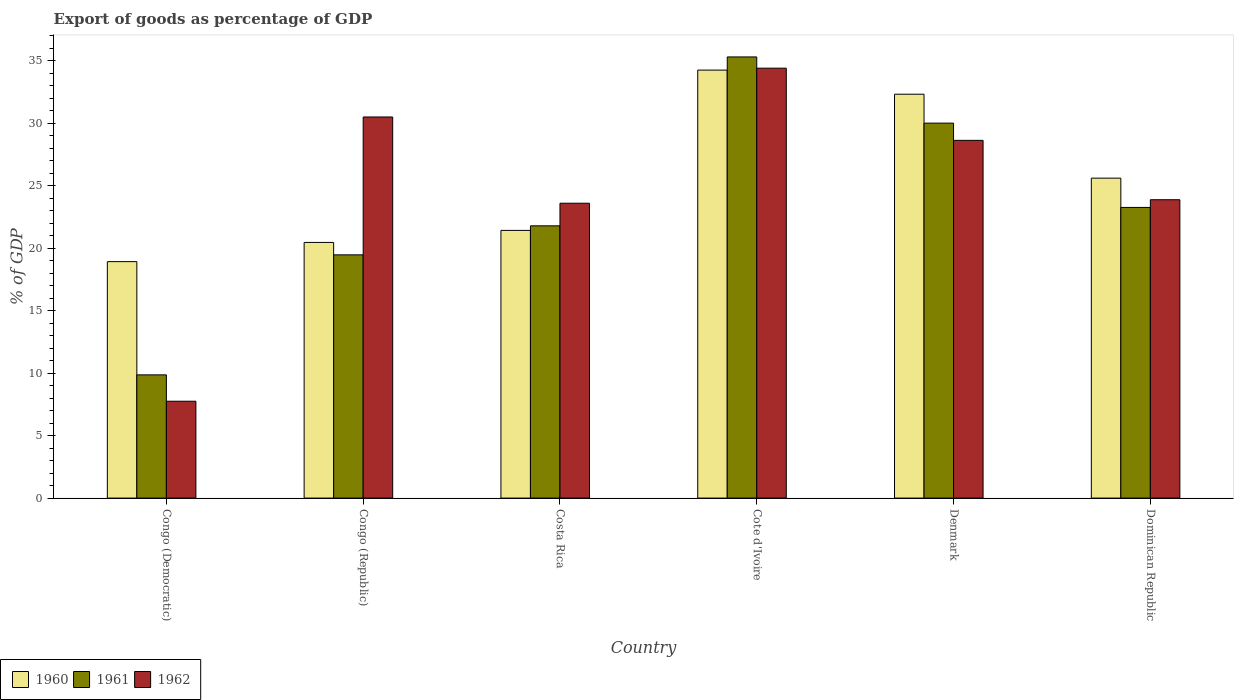How many bars are there on the 2nd tick from the right?
Your response must be concise. 3. What is the label of the 2nd group of bars from the left?
Provide a succinct answer. Congo (Republic). In how many cases, is the number of bars for a given country not equal to the number of legend labels?
Your answer should be very brief. 0. What is the export of goods as percentage of GDP in 1960 in Dominican Republic?
Offer a terse response. 25.59. Across all countries, what is the maximum export of goods as percentage of GDP in 1960?
Ensure brevity in your answer.  34.24. Across all countries, what is the minimum export of goods as percentage of GDP in 1962?
Give a very brief answer. 7.75. In which country was the export of goods as percentage of GDP in 1962 maximum?
Offer a very short reply. Cote d'Ivoire. In which country was the export of goods as percentage of GDP in 1962 minimum?
Provide a succinct answer. Congo (Democratic). What is the total export of goods as percentage of GDP in 1960 in the graph?
Your answer should be compact. 152.93. What is the difference between the export of goods as percentage of GDP in 1962 in Cote d'Ivoire and that in Dominican Republic?
Give a very brief answer. 10.52. What is the difference between the export of goods as percentage of GDP in 1962 in Dominican Republic and the export of goods as percentage of GDP in 1961 in Denmark?
Keep it short and to the point. -6.13. What is the average export of goods as percentage of GDP in 1962 per country?
Give a very brief answer. 24.78. What is the difference between the export of goods as percentage of GDP of/in 1960 and export of goods as percentage of GDP of/in 1961 in Denmark?
Offer a terse response. 2.31. What is the ratio of the export of goods as percentage of GDP in 1961 in Congo (Democratic) to that in Denmark?
Your answer should be very brief. 0.33. Is the export of goods as percentage of GDP in 1960 in Costa Rica less than that in Dominican Republic?
Keep it short and to the point. Yes. Is the difference between the export of goods as percentage of GDP in 1960 in Congo (Republic) and Costa Rica greater than the difference between the export of goods as percentage of GDP in 1961 in Congo (Republic) and Costa Rica?
Provide a succinct answer. Yes. What is the difference between the highest and the second highest export of goods as percentage of GDP in 1960?
Your answer should be compact. 6.72. What is the difference between the highest and the lowest export of goods as percentage of GDP in 1961?
Your answer should be very brief. 25.43. Is the sum of the export of goods as percentage of GDP in 1960 in Cote d'Ivoire and Denmark greater than the maximum export of goods as percentage of GDP in 1961 across all countries?
Your answer should be very brief. Yes. What does the 1st bar from the right in Congo (Republic) represents?
Your answer should be compact. 1962. Are all the bars in the graph horizontal?
Keep it short and to the point. No. What is the difference between two consecutive major ticks on the Y-axis?
Provide a short and direct response. 5. Does the graph contain grids?
Provide a short and direct response. No. How many legend labels are there?
Keep it short and to the point. 3. How are the legend labels stacked?
Provide a succinct answer. Horizontal. What is the title of the graph?
Ensure brevity in your answer.  Export of goods as percentage of GDP. Does "1989" appear as one of the legend labels in the graph?
Your answer should be compact. No. What is the label or title of the Y-axis?
Keep it short and to the point. % of GDP. What is the % of GDP of 1960 in Congo (Democratic)?
Provide a succinct answer. 18.92. What is the % of GDP in 1961 in Congo (Democratic)?
Offer a very short reply. 9.86. What is the % of GDP of 1962 in Congo (Democratic)?
Offer a terse response. 7.75. What is the % of GDP in 1960 in Congo (Republic)?
Your response must be concise. 20.45. What is the % of GDP of 1961 in Congo (Republic)?
Your answer should be compact. 19.46. What is the % of GDP of 1962 in Congo (Republic)?
Keep it short and to the point. 30.49. What is the % of GDP in 1960 in Costa Rica?
Ensure brevity in your answer.  21.42. What is the % of GDP in 1961 in Costa Rica?
Make the answer very short. 21.78. What is the % of GDP of 1962 in Costa Rica?
Keep it short and to the point. 23.59. What is the % of GDP of 1960 in Cote d'Ivoire?
Keep it short and to the point. 34.24. What is the % of GDP of 1961 in Cote d'Ivoire?
Offer a terse response. 35.29. What is the % of GDP in 1962 in Cote d'Ivoire?
Ensure brevity in your answer.  34.39. What is the % of GDP of 1960 in Denmark?
Provide a succinct answer. 32.31. What is the % of GDP of 1961 in Denmark?
Provide a succinct answer. 30. What is the % of GDP in 1962 in Denmark?
Give a very brief answer. 28.62. What is the % of GDP in 1960 in Dominican Republic?
Offer a terse response. 25.59. What is the % of GDP of 1961 in Dominican Republic?
Offer a very short reply. 23.25. What is the % of GDP in 1962 in Dominican Republic?
Offer a terse response. 23.87. Across all countries, what is the maximum % of GDP of 1960?
Make the answer very short. 34.24. Across all countries, what is the maximum % of GDP of 1961?
Ensure brevity in your answer.  35.29. Across all countries, what is the maximum % of GDP in 1962?
Keep it short and to the point. 34.39. Across all countries, what is the minimum % of GDP of 1960?
Ensure brevity in your answer.  18.92. Across all countries, what is the minimum % of GDP in 1961?
Ensure brevity in your answer.  9.86. Across all countries, what is the minimum % of GDP in 1962?
Give a very brief answer. 7.75. What is the total % of GDP in 1960 in the graph?
Provide a succinct answer. 152.93. What is the total % of GDP in 1961 in the graph?
Your response must be concise. 139.64. What is the total % of GDP in 1962 in the graph?
Make the answer very short. 148.71. What is the difference between the % of GDP in 1960 in Congo (Democratic) and that in Congo (Republic)?
Provide a succinct answer. -1.54. What is the difference between the % of GDP of 1961 in Congo (Democratic) and that in Congo (Republic)?
Make the answer very short. -9.6. What is the difference between the % of GDP in 1962 in Congo (Democratic) and that in Congo (Republic)?
Offer a very short reply. -22.74. What is the difference between the % of GDP in 1960 in Congo (Democratic) and that in Costa Rica?
Offer a terse response. -2.5. What is the difference between the % of GDP in 1961 in Congo (Democratic) and that in Costa Rica?
Give a very brief answer. -11.92. What is the difference between the % of GDP in 1962 in Congo (Democratic) and that in Costa Rica?
Your answer should be compact. -15.84. What is the difference between the % of GDP in 1960 in Congo (Democratic) and that in Cote d'Ivoire?
Ensure brevity in your answer.  -15.32. What is the difference between the % of GDP in 1961 in Congo (Democratic) and that in Cote d'Ivoire?
Your response must be concise. -25.43. What is the difference between the % of GDP in 1962 in Congo (Democratic) and that in Cote d'Ivoire?
Your answer should be very brief. -26.64. What is the difference between the % of GDP in 1960 in Congo (Democratic) and that in Denmark?
Offer a very short reply. -13.39. What is the difference between the % of GDP of 1961 in Congo (Democratic) and that in Denmark?
Make the answer very short. -20.14. What is the difference between the % of GDP of 1962 in Congo (Democratic) and that in Denmark?
Ensure brevity in your answer.  -20.87. What is the difference between the % of GDP in 1960 in Congo (Democratic) and that in Dominican Republic?
Your answer should be very brief. -6.68. What is the difference between the % of GDP in 1961 in Congo (Democratic) and that in Dominican Republic?
Keep it short and to the point. -13.4. What is the difference between the % of GDP in 1962 in Congo (Democratic) and that in Dominican Republic?
Make the answer very short. -16.12. What is the difference between the % of GDP of 1960 in Congo (Republic) and that in Costa Rica?
Keep it short and to the point. -0.96. What is the difference between the % of GDP in 1961 in Congo (Republic) and that in Costa Rica?
Give a very brief answer. -2.32. What is the difference between the % of GDP in 1962 in Congo (Republic) and that in Costa Rica?
Your response must be concise. 6.9. What is the difference between the % of GDP of 1960 in Congo (Republic) and that in Cote d'Ivoire?
Offer a terse response. -13.79. What is the difference between the % of GDP in 1961 in Congo (Republic) and that in Cote d'Ivoire?
Offer a very short reply. -15.83. What is the difference between the % of GDP in 1962 in Congo (Republic) and that in Cote d'Ivoire?
Make the answer very short. -3.9. What is the difference between the % of GDP of 1960 in Congo (Republic) and that in Denmark?
Make the answer very short. -11.86. What is the difference between the % of GDP of 1961 in Congo (Republic) and that in Denmark?
Make the answer very short. -10.54. What is the difference between the % of GDP in 1962 in Congo (Republic) and that in Denmark?
Your answer should be compact. 1.87. What is the difference between the % of GDP of 1960 in Congo (Republic) and that in Dominican Republic?
Offer a terse response. -5.14. What is the difference between the % of GDP of 1961 in Congo (Republic) and that in Dominican Republic?
Provide a short and direct response. -3.79. What is the difference between the % of GDP of 1962 in Congo (Republic) and that in Dominican Republic?
Your response must be concise. 6.62. What is the difference between the % of GDP of 1960 in Costa Rica and that in Cote d'Ivoire?
Ensure brevity in your answer.  -12.82. What is the difference between the % of GDP in 1961 in Costa Rica and that in Cote d'Ivoire?
Offer a very short reply. -13.51. What is the difference between the % of GDP of 1962 in Costa Rica and that in Cote d'Ivoire?
Your answer should be very brief. -10.8. What is the difference between the % of GDP in 1960 in Costa Rica and that in Denmark?
Your answer should be compact. -10.89. What is the difference between the % of GDP of 1961 in Costa Rica and that in Denmark?
Your answer should be compact. -8.22. What is the difference between the % of GDP in 1962 in Costa Rica and that in Denmark?
Give a very brief answer. -5.03. What is the difference between the % of GDP of 1960 in Costa Rica and that in Dominican Republic?
Give a very brief answer. -4.18. What is the difference between the % of GDP in 1961 in Costa Rica and that in Dominican Republic?
Ensure brevity in your answer.  -1.47. What is the difference between the % of GDP in 1962 in Costa Rica and that in Dominican Republic?
Ensure brevity in your answer.  -0.28. What is the difference between the % of GDP of 1960 in Cote d'Ivoire and that in Denmark?
Offer a very short reply. 1.93. What is the difference between the % of GDP of 1961 in Cote d'Ivoire and that in Denmark?
Ensure brevity in your answer.  5.3. What is the difference between the % of GDP in 1962 in Cote d'Ivoire and that in Denmark?
Your answer should be very brief. 5.77. What is the difference between the % of GDP of 1960 in Cote d'Ivoire and that in Dominican Republic?
Keep it short and to the point. 8.64. What is the difference between the % of GDP of 1961 in Cote d'Ivoire and that in Dominican Republic?
Offer a terse response. 12.04. What is the difference between the % of GDP of 1962 in Cote d'Ivoire and that in Dominican Republic?
Make the answer very short. 10.52. What is the difference between the % of GDP of 1960 in Denmark and that in Dominican Republic?
Keep it short and to the point. 6.72. What is the difference between the % of GDP of 1961 in Denmark and that in Dominican Republic?
Keep it short and to the point. 6.74. What is the difference between the % of GDP of 1962 in Denmark and that in Dominican Republic?
Keep it short and to the point. 4.75. What is the difference between the % of GDP in 1960 in Congo (Democratic) and the % of GDP in 1961 in Congo (Republic)?
Offer a terse response. -0.54. What is the difference between the % of GDP of 1960 in Congo (Democratic) and the % of GDP of 1962 in Congo (Republic)?
Your answer should be compact. -11.57. What is the difference between the % of GDP of 1961 in Congo (Democratic) and the % of GDP of 1962 in Congo (Republic)?
Ensure brevity in your answer.  -20.63. What is the difference between the % of GDP in 1960 in Congo (Democratic) and the % of GDP in 1961 in Costa Rica?
Provide a short and direct response. -2.86. What is the difference between the % of GDP in 1960 in Congo (Democratic) and the % of GDP in 1962 in Costa Rica?
Offer a terse response. -4.67. What is the difference between the % of GDP of 1961 in Congo (Democratic) and the % of GDP of 1962 in Costa Rica?
Offer a very short reply. -13.73. What is the difference between the % of GDP of 1960 in Congo (Democratic) and the % of GDP of 1961 in Cote d'Ivoire?
Your response must be concise. -16.38. What is the difference between the % of GDP in 1960 in Congo (Democratic) and the % of GDP in 1962 in Cote d'Ivoire?
Make the answer very short. -15.48. What is the difference between the % of GDP in 1961 in Congo (Democratic) and the % of GDP in 1962 in Cote d'Ivoire?
Offer a terse response. -24.53. What is the difference between the % of GDP of 1960 in Congo (Democratic) and the % of GDP of 1961 in Denmark?
Keep it short and to the point. -11.08. What is the difference between the % of GDP of 1960 in Congo (Democratic) and the % of GDP of 1962 in Denmark?
Your answer should be very brief. -9.7. What is the difference between the % of GDP in 1961 in Congo (Democratic) and the % of GDP in 1962 in Denmark?
Provide a short and direct response. -18.76. What is the difference between the % of GDP of 1960 in Congo (Democratic) and the % of GDP of 1961 in Dominican Republic?
Provide a succinct answer. -4.34. What is the difference between the % of GDP of 1960 in Congo (Democratic) and the % of GDP of 1962 in Dominican Republic?
Keep it short and to the point. -4.95. What is the difference between the % of GDP of 1961 in Congo (Democratic) and the % of GDP of 1962 in Dominican Republic?
Ensure brevity in your answer.  -14.01. What is the difference between the % of GDP of 1960 in Congo (Republic) and the % of GDP of 1961 in Costa Rica?
Keep it short and to the point. -1.33. What is the difference between the % of GDP in 1960 in Congo (Republic) and the % of GDP in 1962 in Costa Rica?
Offer a very short reply. -3.14. What is the difference between the % of GDP of 1961 in Congo (Republic) and the % of GDP of 1962 in Costa Rica?
Your answer should be compact. -4.13. What is the difference between the % of GDP of 1960 in Congo (Republic) and the % of GDP of 1961 in Cote d'Ivoire?
Keep it short and to the point. -14.84. What is the difference between the % of GDP in 1960 in Congo (Republic) and the % of GDP in 1962 in Cote d'Ivoire?
Provide a succinct answer. -13.94. What is the difference between the % of GDP in 1961 in Congo (Republic) and the % of GDP in 1962 in Cote d'Ivoire?
Make the answer very short. -14.93. What is the difference between the % of GDP in 1960 in Congo (Republic) and the % of GDP in 1961 in Denmark?
Your answer should be very brief. -9.54. What is the difference between the % of GDP of 1960 in Congo (Republic) and the % of GDP of 1962 in Denmark?
Offer a very short reply. -8.17. What is the difference between the % of GDP of 1961 in Congo (Republic) and the % of GDP of 1962 in Denmark?
Your response must be concise. -9.16. What is the difference between the % of GDP of 1960 in Congo (Republic) and the % of GDP of 1961 in Dominican Republic?
Keep it short and to the point. -2.8. What is the difference between the % of GDP of 1960 in Congo (Republic) and the % of GDP of 1962 in Dominican Republic?
Ensure brevity in your answer.  -3.42. What is the difference between the % of GDP of 1961 in Congo (Republic) and the % of GDP of 1962 in Dominican Republic?
Give a very brief answer. -4.41. What is the difference between the % of GDP in 1960 in Costa Rica and the % of GDP in 1961 in Cote d'Ivoire?
Ensure brevity in your answer.  -13.88. What is the difference between the % of GDP in 1960 in Costa Rica and the % of GDP in 1962 in Cote d'Ivoire?
Ensure brevity in your answer.  -12.98. What is the difference between the % of GDP in 1961 in Costa Rica and the % of GDP in 1962 in Cote d'Ivoire?
Offer a terse response. -12.61. What is the difference between the % of GDP in 1960 in Costa Rica and the % of GDP in 1961 in Denmark?
Ensure brevity in your answer.  -8.58. What is the difference between the % of GDP of 1960 in Costa Rica and the % of GDP of 1962 in Denmark?
Offer a terse response. -7.2. What is the difference between the % of GDP of 1961 in Costa Rica and the % of GDP of 1962 in Denmark?
Ensure brevity in your answer.  -6.84. What is the difference between the % of GDP of 1960 in Costa Rica and the % of GDP of 1961 in Dominican Republic?
Give a very brief answer. -1.84. What is the difference between the % of GDP of 1960 in Costa Rica and the % of GDP of 1962 in Dominican Republic?
Make the answer very short. -2.45. What is the difference between the % of GDP of 1961 in Costa Rica and the % of GDP of 1962 in Dominican Republic?
Keep it short and to the point. -2.09. What is the difference between the % of GDP of 1960 in Cote d'Ivoire and the % of GDP of 1961 in Denmark?
Your answer should be compact. 4.24. What is the difference between the % of GDP of 1960 in Cote d'Ivoire and the % of GDP of 1962 in Denmark?
Your answer should be compact. 5.62. What is the difference between the % of GDP in 1961 in Cote d'Ivoire and the % of GDP in 1962 in Denmark?
Give a very brief answer. 6.67. What is the difference between the % of GDP of 1960 in Cote d'Ivoire and the % of GDP of 1961 in Dominican Republic?
Ensure brevity in your answer.  10.99. What is the difference between the % of GDP of 1960 in Cote d'Ivoire and the % of GDP of 1962 in Dominican Republic?
Ensure brevity in your answer.  10.37. What is the difference between the % of GDP of 1961 in Cote d'Ivoire and the % of GDP of 1962 in Dominican Republic?
Your answer should be very brief. 11.42. What is the difference between the % of GDP in 1960 in Denmark and the % of GDP in 1961 in Dominican Republic?
Make the answer very short. 9.06. What is the difference between the % of GDP of 1960 in Denmark and the % of GDP of 1962 in Dominican Republic?
Your answer should be compact. 8.44. What is the difference between the % of GDP of 1961 in Denmark and the % of GDP of 1962 in Dominican Republic?
Ensure brevity in your answer.  6.13. What is the average % of GDP in 1960 per country?
Offer a terse response. 25.49. What is the average % of GDP in 1961 per country?
Your response must be concise. 23.27. What is the average % of GDP of 1962 per country?
Ensure brevity in your answer.  24.78. What is the difference between the % of GDP in 1960 and % of GDP in 1961 in Congo (Democratic)?
Your response must be concise. 9.06. What is the difference between the % of GDP of 1960 and % of GDP of 1962 in Congo (Democratic)?
Your answer should be compact. 11.17. What is the difference between the % of GDP of 1961 and % of GDP of 1962 in Congo (Democratic)?
Provide a succinct answer. 2.11. What is the difference between the % of GDP in 1960 and % of GDP in 1962 in Congo (Republic)?
Your answer should be very brief. -10.04. What is the difference between the % of GDP of 1961 and % of GDP of 1962 in Congo (Republic)?
Give a very brief answer. -11.03. What is the difference between the % of GDP in 1960 and % of GDP in 1961 in Costa Rica?
Offer a very short reply. -0.36. What is the difference between the % of GDP of 1960 and % of GDP of 1962 in Costa Rica?
Your answer should be very brief. -2.17. What is the difference between the % of GDP of 1961 and % of GDP of 1962 in Costa Rica?
Keep it short and to the point. -1.81. What is the difference between the % of GDP of 1960 and % of GDP of 1961 in Cote d'Ivoire?
Give a very brief answer. -1.05. What is the difference between the % of GDP in 1960 and % of GDP in 1962 in Cote d'Ivoire?
Provide a succinct answer. -0.15. What is the difference between the % of GDP of 1961 and % of GDP of 1962 in Cote d'Ivoire?
Your answer should be compact. 0.9. What is the difference between the % of GDP in 1960 and % of GDP in 1961 in Denmark?
Your answer should be very brief. 2.31. What is the difference between the % of GDP of 1960 and % of GDP of 1962 in Denmark?
Offer a very short reply. 3.69. What is the difference between the % of GDP of 1961 and % of GDP of 1962 in Denmark?
Provide a short and direct response. 1.38. What is the difference between the % of GDP in 1960 and % of GDP in 1961 in Dominican Republic?
Your answer should be compact. 2.34. What is the difference between the % of GDP of 1960 and % of GDP of 1962 in Dominican Republic?
Your answer should be compact. 1.73. What is the difference between the % of GDP of 1961 and % of GDP of 1962 in Dominican Republic?
Your answer should be very brief. -0.62. What is the ratio of the % of GDP in 1960 in Congo (Democratic) to that in Congo (Republic)?
Your answer should be very brief. 0.92. What is the ratio of the % of GDP of 1961 in Congo (Democratic) to that in Congo (Republic)?
Offer a terse response. 0.51. What is the ratio of the % of GDP in 1962 in Congo (Democratic) to that in Congo (Republic)?
Provide a succinct answer. 0.25. What is the ratio of the % of GDP in 1960 in Congo (Democratic) to that in Costa Rica?
Your response must be concise. 0.88. What is the ratio of the % of GDP in 1961 in Congo (Democratic) to that in Costa Rica?
Make the answer very short. 0.45. What is the ratio of the % of GDP of 1962 in Congo (Democratic) to that in Costa Rica?
Offer a very short reply. 0.33. What is the ratio of the % of GDP in 1960 in Congo (Democratic) to that in Cote d'Ivoire?
Keep it short and to the point. 0.55. What is the ratio of the % of GDP in 1961 in Congo (Democratic) to that in Cote d'Ivoire?
Ensure brevity in your answer.  0.28. What is the ratio of the % of GDP in 1962 in Congo (Democratic) to that in Cote d'Ivoire?
Offer a terse response. 0.23. What is the ratio of the % of GDP of 1960 in Congo (Democratic) to that in Denmark?
Your response must be concise. 0.59. What is the ratio of the % of GDP of 1961 in Congo (Democratic) to that in Denmark?
Your answer should be compact. 0.33. What is the ratio of the % of GDP in 1962 in Congo (Democratic) to that in Denmark?
Provide a short and direct response. 0.27. What is the ratio of the % of GDP of 1960 in Congo (Democratic) to that in Dominican Republic?
Offer a terse response. 0.74. What is the ratio of the % of GDP of 1961 in Congo (Democratic) to that in Dominican Republic?
Your answer should be very brief. 0.42. What is the ratio of the % of GDP of 1962 in Congo (Democratic) to that in Dominican Republic?
Provide a short and direct response. 0.32. What is the ratio of the % of GDP of 1960 in Congo (Republic) to that in Costa Rica?
Provide a short and direct response. 0.96. What is the ratio of the % of GDP of 1961 in Congo (Republic) to that in Costa Rica?
Provide a succinct answer. 0.89. What is the ratio of the % of GDP of 1962 in Congo (Republic) to that in Costa Rica?
Ensure brevity in your answer.  1.29. What is the ratio of the % of GDP of 1960 in Congo (Republic) to that in Cote d'Ivoire?
Ensure brevity in your answer.  0.6. What is the ratio of the % of GDP in 1961 in Congo (Republic) to that in Cote d'Ivoire?
Your response must be concise. 0.55. What is the ratio of the % of GDP in 1962 in Congo (Republic) to that in Cote d'Ivoire?
Your response must be concise. 0.89. What is the ratio of the % of GDP in 1960 in Congo (Republic) to that in Denmark?
Ensure brevity in your answer.  0.63. What is the ratio of the % of GDP in 1961 in Congo (Republic) to that in Denmark?
Keep it short and to the point. 0.65. What is the ratio of the % of GDP of 1962 in Congo (Republic) to that in Denmark?
Offer a very short reply. 1.07. What is the ratio of the % of GDP of 1960 in Congo (Republic) to that in Dominican Republic?
Ensure brevity in your answer.  0.8. What is the ratio of the % of GDP of 1961 in Congo (Republic) to that in Dominican Republic?
Give a very brief answer. 0.84. What is the ratio of the % of GDP of 1962 in Congo (Republic) to that in Dominican Republic?
Offer a terse response. 1.28. What is the ratio of the % of GDP in 1960 in Costa Rica to that in Cote d'Ivoire?
Offer a terse response. 0.63. What is the ratio of the % of GDP of 1961 in Costa Rica to that in Cote d'Ivoire?
Offer a terse response. 0.62. What is the ratio of the % of GDP in 1962 in Costa Rica to that in Cote d'Ivoire?
Provide a succinct answer. 0.69. What is the ratio of the % of GDP in 1960 in Costa Rica to that in Denmark?
Offer a terse response. 0.66. What is the ratio of the % of GDP in 1961 in Costa Rica to that in Denmark?
Ensure brevity in your answer.  0.73. What is the ratio of the % of GDP in 1962 in Costa Rica to that in Denmark?
Your answer should be compact. 0.82. What is the ratio of the % of GDP of 1960 in Costa Rica to that in Dominican Republic?
Provide a short and direct response. 0.84. What is the ratio of the % of GDP of 1961 in Costa Rica to that in Dominican Republic?
Provide a short and direct response. 0.94. What is the ratio of the % of GDP of 1962 in Costa Rica to that in Dominican Republic?
Your response must be concise. 0.99. What is the ratio of the % of GDP in 1960 in Cote d'Ivoire to that in Denmark?
Keep it short and to the point. 1.06. What is the ratio of the % of GDP of 1961 in Cote d'Ivoire to that in Denmark?
Your answer should be compact. 1.18. What is the ratio of the % of GDP in 1962 in Cote d'Ivoire to that in Denmark?
Your answer should be very brief. 1.2. What is the ratio of the % of GDP of 1960 in Cote d'Ivoire to that in Dominican Republic?
Offer a very short reply. 1.34. What is the ratio of the % of GDP in 1961 in Cote d'Ivoire to that in Dominican Republic?
Provide a succinct answer. 1.52. What is the ratio of the % of GDP in 1962 in Cote d'Ivoire to that in Dominican Republic?
Give a very brief answer. 1.44. What is the ratio of the % of GDP of 1960 in Denmark to that in Dominican Republic?
Your response must be concise. 1.26. What is the ratio of the % of GDP in 1961 in Denmark to that in Dominican Republic?
Your answer should be very brief. 1.29. What is the ratio of the % of GDP of 1962 in Denmark to that in Dominican Republic?
Give a very brief answer. 1.2. What is the difference between the highest and the second highest % of GDP in 1960?
Make the answer very short. 1.93. What is the difference between the highest and the second highest % of GDP of 1961?
Your response must be concise. 5.3. What is the difference between the highest and the second highest % of GDP of 1962?
Give a very brief answer. 3.9. What is the difference between the highest and the lowest % of GDP in 1960?
Ensure brevity in your answer.  15.32. What is the difference between the highest and the lowest % of GDP in 1961?
Offer a very short reply. 25.43. What is the difference between the highest and the lowest % of GDP of 1962?
Make the answer very short. 26.64. 